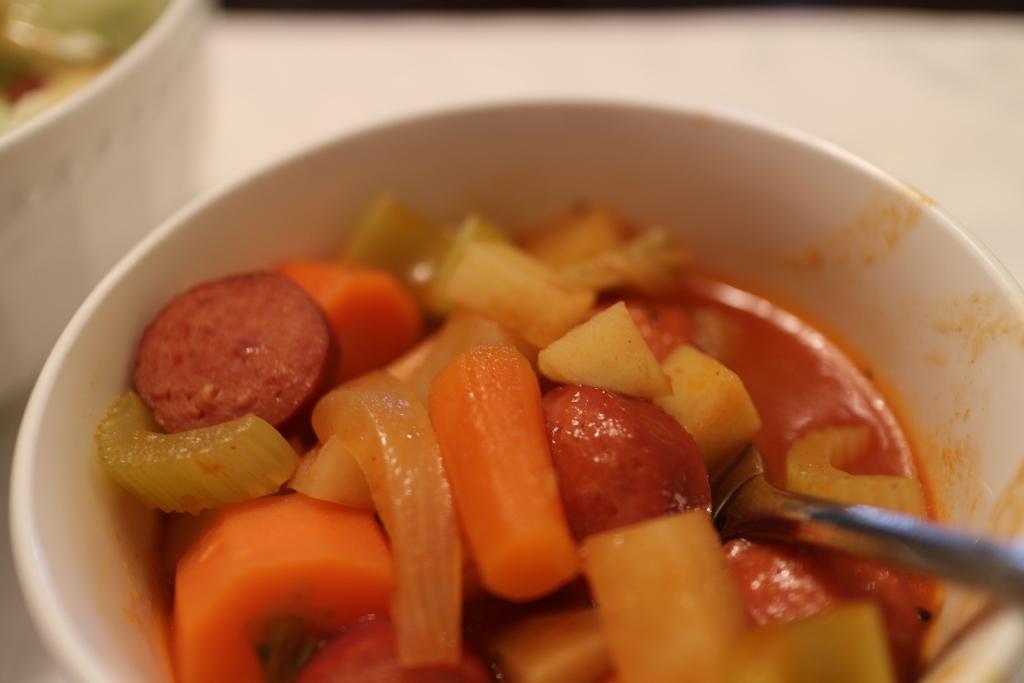Please provide a concise description of this image. In this image we can see food item and spoon in a bowl and an object are on a platform. 